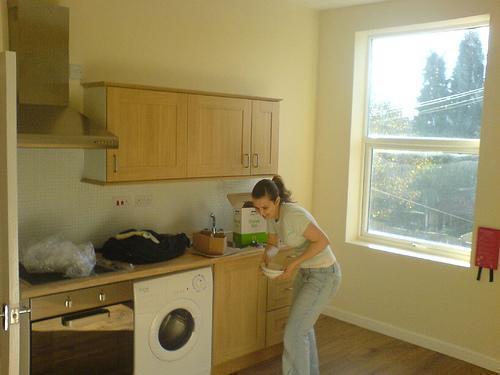What is the woman using the bowl for here?
Select the accurate response from the four choices given to answer the question.
Options: Hidden camera, feeding baby, feed pet, trapping rats. Feed pet. 